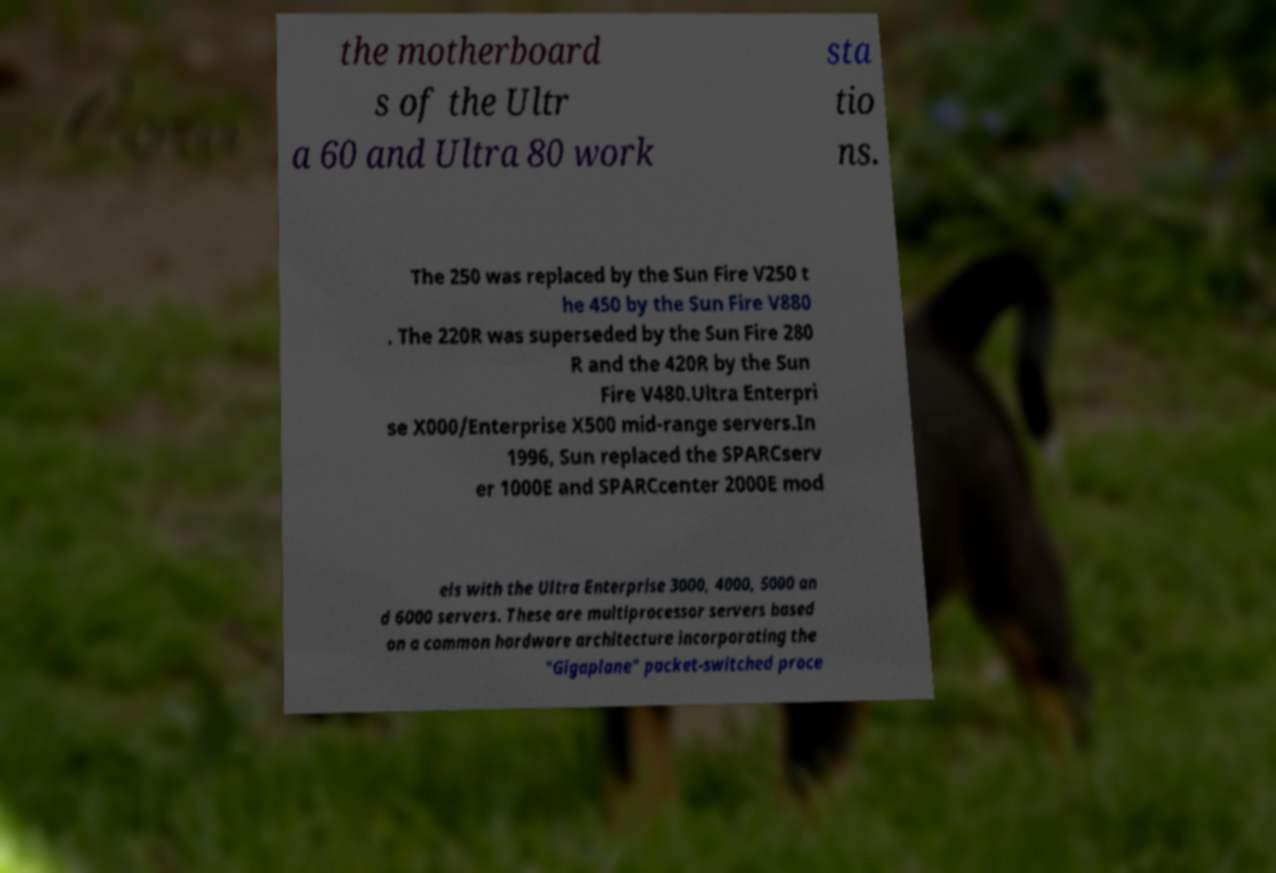I need the written content from this picture converted into text. Can you do that? the motherboard s of the Ultr a 60 and Ultra 80 work sta tio ns. The 250 was replaced by the Sun Fire V250 t he 450 by the Sun Fire V880 . The 220R was superseded by the Sun Fire 280 R and the 420R by the Sun Fire V480.Ultra Enterpri se X000/Enterprise X500 mid-range servers.In 1996, Sun replaced the SPARCserv er 1000E and SPARCcenter 2000E mod els with the Ultra Enterprise 3000, 4000, 5000 an d 6000 servers. These are multiprocessor servers based on a common hardware architecture incorporating the "Gigaplane" packet-switched proce 